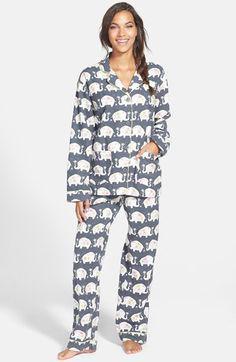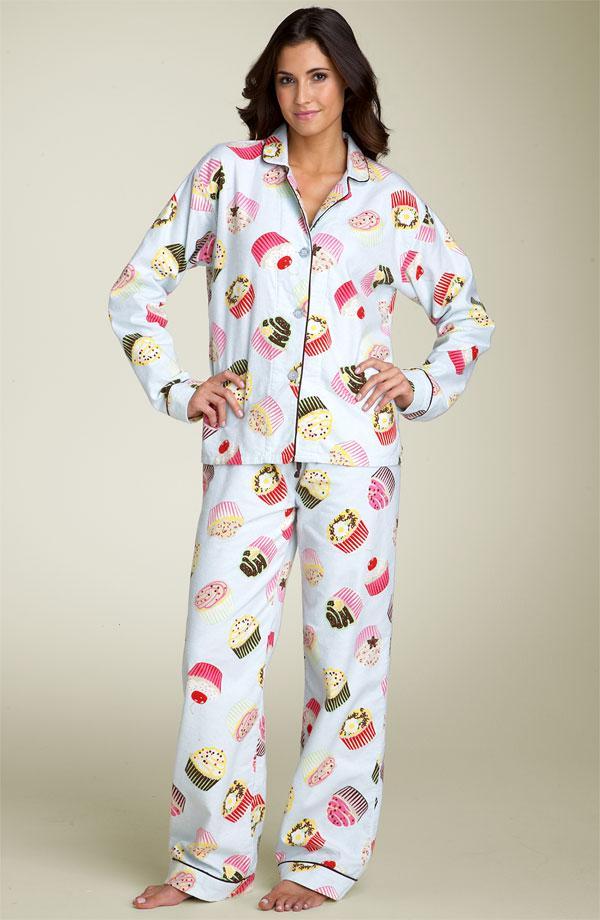The first image is the image on the left, the second image is the image on the right. Evaluate the accuracy of this statement regarding the images: "The woman in the right image has one hand on her waist in posing position.". Is it true? Answer yes or no. No. 